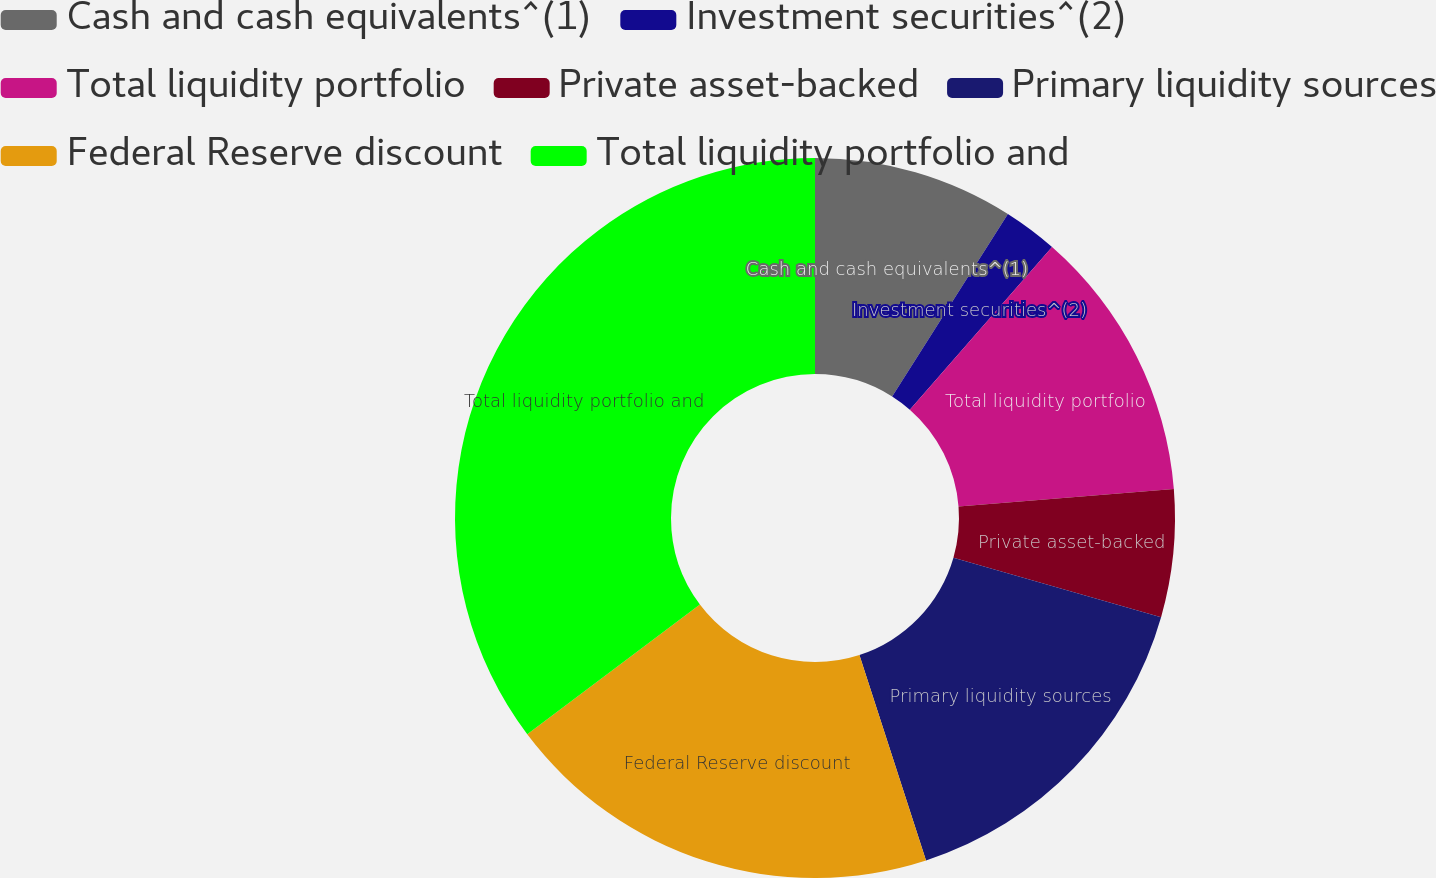Convert chart to OTSL. <chart><loc_0><loc_0><loc_500><loc_500><pie_chart><fcel>Cash and cash equivalents^(1)<fcel>Investment securities^(2)<fcel>Total liquidity portfolio<fcel>Private asset-backed<fcel>Primary liquidity sources<fcel>Federal Reserve discount<fcel>Total liquidity portfolio and<nl><fcel>9.0%<fcel>2.44%<fcel>12.28%<fcel>5.72%<fcel>15.57%<fcel>19.73%<fcel>35.26%<nl></chart> 